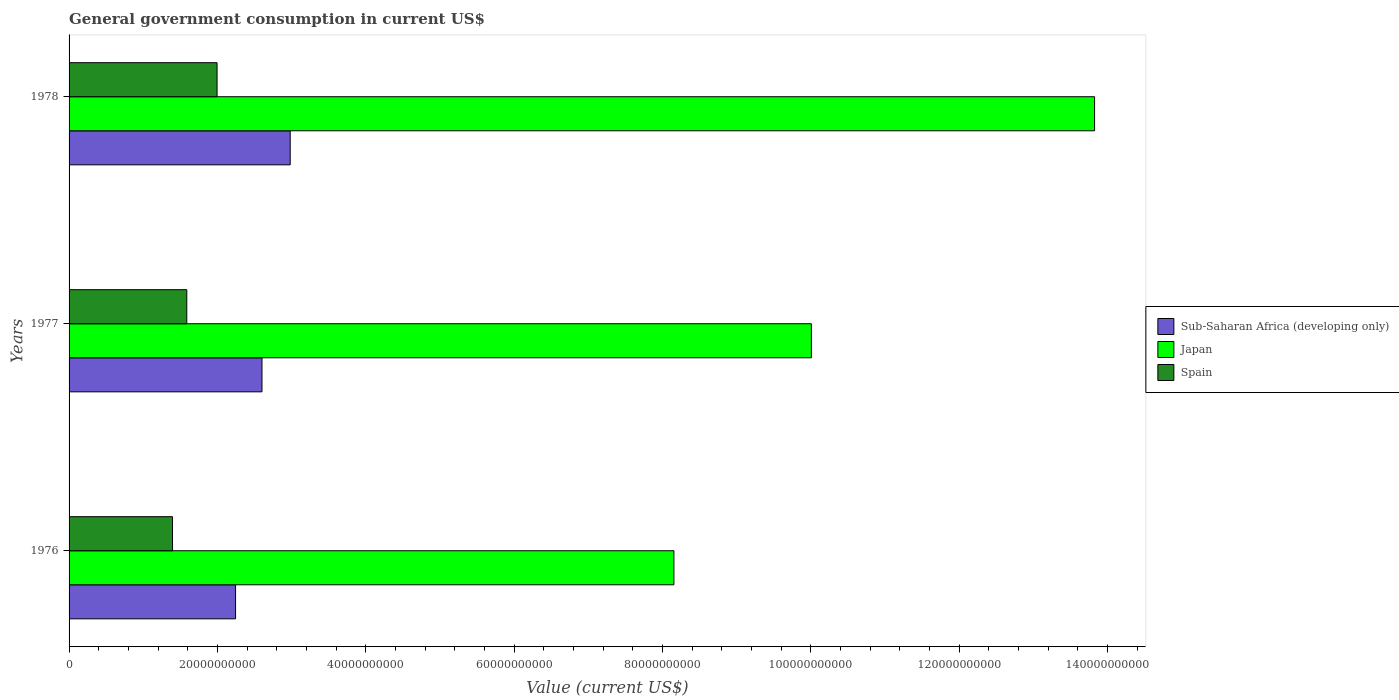In how many cases, is the number of bars for a given year not equal to the number of legend labels?
Offer a very short reply. 0. What is the government conusmption in Sub-Saharan Africa (developing only) in 1978?
Provide a succinct answer. 2.98e+1. Across all years, what is the maximum government conusmption in Sub-Saharan Africa (developing only)?
Offer a terse response. 2.98e+1. Across all years, what is the minimum government conusmption in Sub-Saharan Africa (developing only)?
Give a very brief answer. 2.24e+1. In which year was the government conusmption in Japan maximum?
Make the answer very short. 1978. In which year was the government conusmption in Japan minimum?
Ensure brevity in your answer.  1976. What is the total government conusmption in Japan in the graph?
Provide a short and direct response. 3.20e+11. What is the difference between the government conusmption in Japan in 1976 and that in 1978?
Ensure brevity in your answer.  -5.67e+1. What is the difference between the government conusmption in Sub-Saharan Africa (developing only) in 1978 and the government conusmption in Japan in 1977?
Your answer should be very brief. -7.03e+1. What is the average government conusmption in Japan per year?
Provide a short and direct response. 1.07e+11. In the year 1977, what is the difference between the government conusmption in Japan and government conusmption in Spain?
Offer a very short reply. 8.42e+1. In how many years, is the government conusmption in Sub-Saharan Africa (developing only) greater than 64000000000 US$?
Your answer should be compact. 0. What is the ratio of the government conusmption in Sub-Saharan Africa (developing only) in 1977 to that in 1978?
Offer a terse response. 0.87. Is the government conusmption in Japan in 1976 less than that in 1978?
Provide a short and direct response. Yes. What is the difference between the highest and the second highest government conusmption in Spain?
Give a very brief answer. 4.08e+09. What is the difference between the highest and the lowest government conusmption in Japan?
Make the answer very short. 5.67e+1. How many bars are there?
Offer a very short reply. 9. Are the values on the major ticks of X-axis written in scientific E-notation?
Keep it short and to the point. No. Does the graph contain any zero values?
Your answer should be very brief. No. What is the title of the graph?
Your answer should be very brief. General government consumption in current US$. What is the label or title of the X-axis?
Your answer should be compact. Value (current US$). What is the label or title of the Y-axis?
Offer a very short reply. Years. What is the Value (current US$) in Sub-Saharan Africa (developing only) in 1976?
Provide a short and direct response. 2.24e+1. What is the Value (current US$) of Japan in 1976?
Your response must be concise. 8.15e+1. What is the Value (current US$) of Spain in 1976?
Provide a succinct answer. 1.39e+1. What is the Value (current US$) of Sub-Saharan Africa (developing only) in 1977?
Offer a very short reply. 2.60e+1. What is the Value (current US$) of Japan in 1977?
Keep it short and to the point. 1.00e+11. What is the Value (current US$) of Spain in 1977?
Offer a very short reply. 1.59e+1. What is the Value (current US$) in Sub-Saharan Africa (developing only) in 1978?
Your answer should be very brief. 2.98e+1. What is the Value (current US$) in Japan in 1978?
Keep it short and to the point. 1.38e+11. What is the Value (current US$) in Spain in 1978?
Keep it short and to the point. 1.99e+1. Across all years, what is the maximum Value (current US$) of Sub-Saharan Africa (developing only)?
Give a very brief answer. 2.98e+1. Across all years, what is the maximum Value (current US$) of Japan?
Offer a terse response. 1.38e+11. Across all years, what is the maximum Value (current US$) in Spain?
Give a very brief answer. 1.99e+1. Across all years, what is the minimum Value (current US$) of Sub-Saharan Africa (developing only)?
Make the answer very short. 2.24e+1. Across all years, what is the minimum Value (current US$) in Japan?
Offer a very short reply. 8.15e+1. Across all years, what is the minimum Value (current US$) in Spain?
Give a very brief answer. 1.39e+1. What is the total Value (current US$) of Sub-Saharan Africa (developing only) in the graph?
Keep it short and to the point. 7.83e+1. What is the total Value (current US$) in Japan in the graph?
Ensure brevity in your answer.  3.20e+11. What is the total Value (current US$) of Spain in the graph?
Ensure brevity in your answer.  4.98e+1. What is the difference between the Value (current US$) in Sub-Saharan Africa (developing only) in 1976 and that in 1977?
Your answer should be compact. -3.56e+09. What is the difference between the Value (current US$) of Japan in 1976 and that in 1977?
Offer a very short reply. -1.85e+1. What is the difference between the Value (current US$) in Spain in 1976 and that in 1977?
Offer a very short reply. -1.92e+09. What is the difference between the Value (current US$) of Sub-Saharan Africa (developing only) in 1976 and that in 1978?
Your answer should be very brief. -7.37e+09. What is the difference between the Value (current US$) of Japan in 1976 and that in 1978?
Ensure brevity in your answer.  -5.67e+1. What is the difference between the Value (current US$) of Spain in 1976 and that in 1978?
Your response must be concise. -6.01e+09. What is the difference between the Value (current US$) of Sub-Saharan Africa (developing only) in 1977 and that in 1978?
Offer a terse response. -3.80e+09. What is the difference between the Value (current US$) of Japan in 1977 and that in 1978?
Your answer should be compact. -3.82e+1. What is the difference between the Value (current US$) in Spain in 1977 and that in 1978?
Make the answer very short. -4.08e+09. What is the difference between the Value (current US$) of Sub-Saharan Africa (developing only) in 1976 and the Value (current US$) of Japan in 1977?
Keep it short and to the point. -7.76e+1. What is the difference between the Value (current US$) of Sub-Saharan Africa (developing only) in 1976 and the Value (current US$) of Spain in 1977?
Your answer should be compact. 6.58e+09. What is the difference between the Value (current US$) of Japan in 1976 and the Value (current US$) of Spain in 1977?
Your response must be concise. 6.57e+1. What is the difference between the Value (current US$) of Sub-Saharan Africa (developing only) in 1976 and the Value (current US$) of Japan in 1978?
Keep it short and to the point. -1.16e+11. What is the difference between the Value (current US$) of Sub-Saharan Africa (developing only) in 1976 and the Value (current US$) of Spain in 1978?
Your response must be concise. 2.49e+09. What is the difference between the Value (current US$) of Japan in 1976 and the Value (current US$) of Spain in 1978?
Ensure brevity in your answer.  6.16e+1. What is the difference between the Value (current US$) of Sub-Saharan Africa (developing only) in 1977 and the Value (current US$) of Japan in 1978?
Provide a succinct answer. -1.12e+11. What is the difference between the Value (current US$) of Sub-Saharan Africa (developing only) in 1977 and the Value (current US$) of Spain in 1978?
Ensure brevity in your answer.  6.06e+09. What is the difference between the Value (current US$) in Japan in 1977 and the Value (current US$) in Spain in 1978?
Make the answer very short. 8.01e+1. What is the average Value (current US$) in Sub-Saharan Africa (developing only) per year?
Keep it short and to the point. 2.61e+1. What is the average Value (current US$) in Japan per year?
Make the answer very short. 1.07e+11. What is the average Value (current US$) of Spain per year?
Keep it short and to the point. 1.66e+1. In the year 1976, what is the difference between the Value (current US$) of Sub-Saharan Africa (developing only) and Value (current US$) of Japan?
Your answer should be compact. -5.91e+1. In the year 1976, what is the difference between the Value (current US$) in Sub-Saharan Africa (developing only) and Value (current US$) in Spain?
Keep it short and to the point. 8.50e+09. In the year 1976, what is the difference between the Value (current US$) of Japan and Value (current US$) of Spain?
Offer a very short reply. 6.76e+1. In the year 1977, what is the difference between the Value (current US$) in Sub-Saharan Africa (developing only) and Value (current US$) in Japan?
Offer a very short reply. -7.41e+1. In the year 1977, what is the difference between the Value (current US$) in Sub-Saharan Africa (developing only) and Value (current US$) in Spain?
Keep it short and to the point. 1.01e+1. In the year 1977, what is the difference between the Value (current US$) of Japan and Value (current US$) of Spain?
Provide a short and direct response. 8.42e+1. In the year 1978, what is the difference between the Value (current US$) of Sub-Saharan Africa (developing only) and Value (current US$) of Japan?
Provide a succinct answer. -1.08e+11. In the year 1978, what is the difference between the Value (current US$) of Sub-Saharan Africa (developing only) and Value (current US$) of Spain?
Offer a very short reply. 9.86e+09. In the year 1978, what is the difference between the Value (current US$) of Japan and Value (current US$) of Spain?
Provide a short and direct response. 1.18e+11. What is the ratio of the Value (current US$) of Sub-Saharan Africa (developing only) in 1976 to that in 1977?
Offer a very short reply. 0.86. What is the ratio of the Value (current US$) in Japan in 1976 to that in 1977?
Ensure brevity in your answer.  0.81. What is the ratio of the Value (current US$) in Spain in 1976 to that in 1977?
Make the answer very short. 0.88. What is the ratio of the Value (current US$) of Sub-Saharan Africa (developing only) in 1976 to that in 1978?
Your answer should be compact. 0.75. What is the ratio of the Value (current US$) in Japan in 1976 to that in 1978?
Make the answer very short. 0.59. What is the ratio of the Value (current US$) of Spain in 1976 to that in 1978?
Offer a terse response. 0.7. What is the ratio of the Value (current US$) of Sub-Saharan Africa (developing only) in 1977 to that in 1978?
Ensure brevity in your answer.  0.87. What is the ratio of the Value (current US$) of Japan in 1977 to that in 1978?
Provide a succinct answer. 0.72. What is the ratio of the Value (current US$) in Spain in 1977 to that in 1978?
Your answer should be very brief. 0.8. What is the difference between the highest and the second highest Value (current US$) in Sub-Saharan Africa (developing only)?
Ensure brevity in your answer.  3.80e+09. What is the difference between the highest and the second highest Value (current US$) of Japan?
Your response must be concise. 3.82e+1. What is the difference between the highest and the second highest Value (current US$) in Spain?
Offer a very short reply. 4.08e+09. What is the difference between the highest and the lowest Value (current US$) in Sub-Saharan Africa (developing only)?
Make the answer very short. 7.37e+09. What is the difference between the highest and the lowest Value (current US$) of Japan?
Provide a succinct answer. 5.67e+1. What is the difference between the highest and the lowest Value (current US$) in Spain?
Keep it short and to the point. 6.01e+09. 